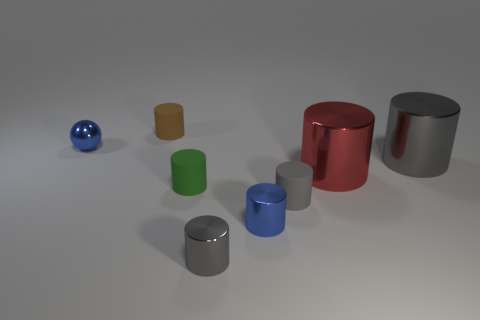How many other things are the same shape as the green matte thing?
Keep it short and to the point. 6. There is a green rubber thing in front of the big red cylinder; what size is it?
Provide a short and direct response. Small. There is a gray metal cylinder that is behind the green cylinder; how many gray matte cylinders are left of it?
Your answer should be very brief. 1. How many other things are the same size as the shiny ball?
Offer a terse response. 5. Is the shape of the blue thing to the right of the small blue shiny sphere the same as  the brown object?
Offer a terse response. Yes. What number of metal things are both behind the red cylinder and on the right side of the shiny sphere?
Give a very brief answer. 1. What is the material of the red cylinder?
Give a very brief answer. Metal. Are there any other things of the same color as the ball?
Give a very brief answer. Yes. Is the material of the tiny blue cylinder the same as the blue sphere?
Your answer should be compact. Yes. How many small green rubber cylinders are to the left of the tiny blue cylinder behind the tiny gray thing that is in front of the gray matte object?
Make the answer very short. 1. 